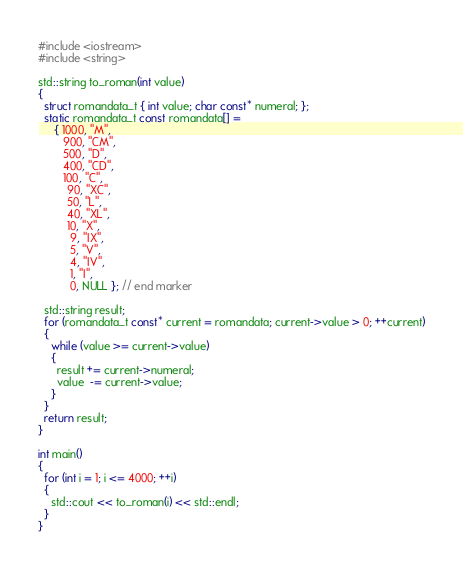<code> <loc_0><loc_0><loc_500><loc_500><_C++_>#include <iostream>
#include <string>

std::string to_roman(int value)
{
  struct romandata_t { int value; char const* numeral; };
  static romandata_t const romandata[] =
     { 1000, "M",
        900, "CM",
        500, "D",
        400, "CD",
        100, "C",
         90, "XC",
         50, "L",
         40, "XL",
         10, "X",
          9, "IX",
          5, "V",
          4, "IV",
          1, "I",
          0, NULL }; // end marker

  std::string result;
  for (romandata_t const* current = romandata; current->value > 0; ++current)
  {
    while (value >= current->value)
    {
      result += current->numeral;
      value  -= current->value;
    }
  }
  return result;
}

int main()
{
  for (int i = 1; i <= 4000; ++i)
  {
    std::cout << to_roman(i) << std::endl;
  }
}
</code> 